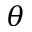Convert formula to latex. <formula><loc_0><loc_0><loc_500><loc_500>\theta</formula> 